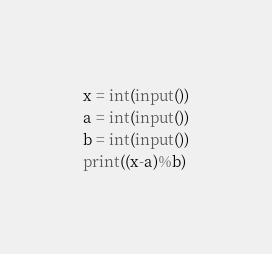Convert code to text. <code><loc_0><loc_0><loc_500><loc_500><_Python_>x = int(input())
a = int(input())
b = int(input())
print((x-a)%b)</code> 